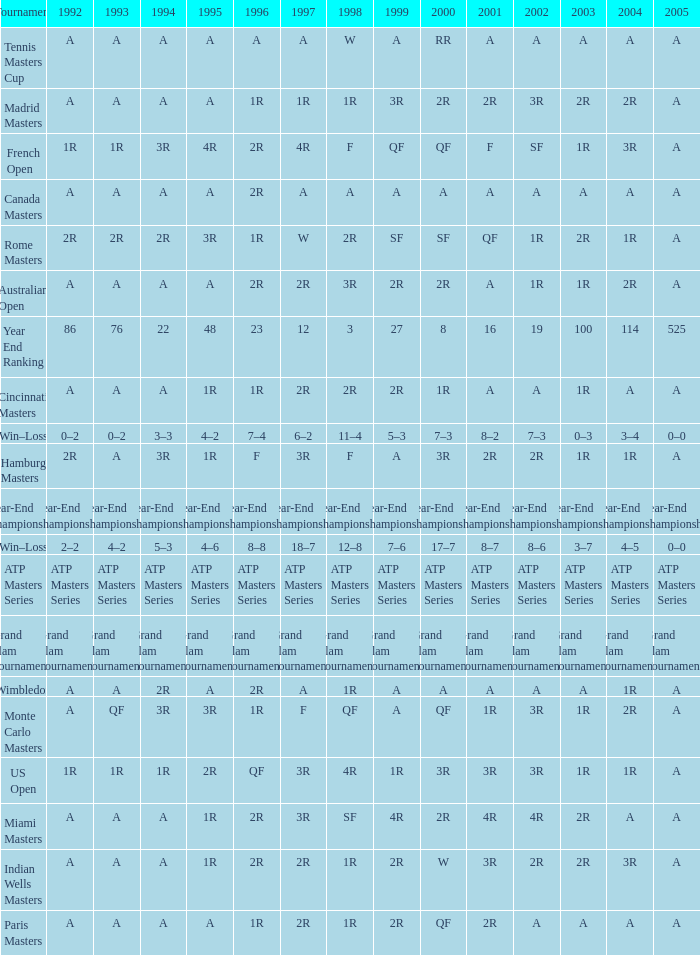What is 1998, when 1997 is "3R", and when 1992 is "A"? SF. 